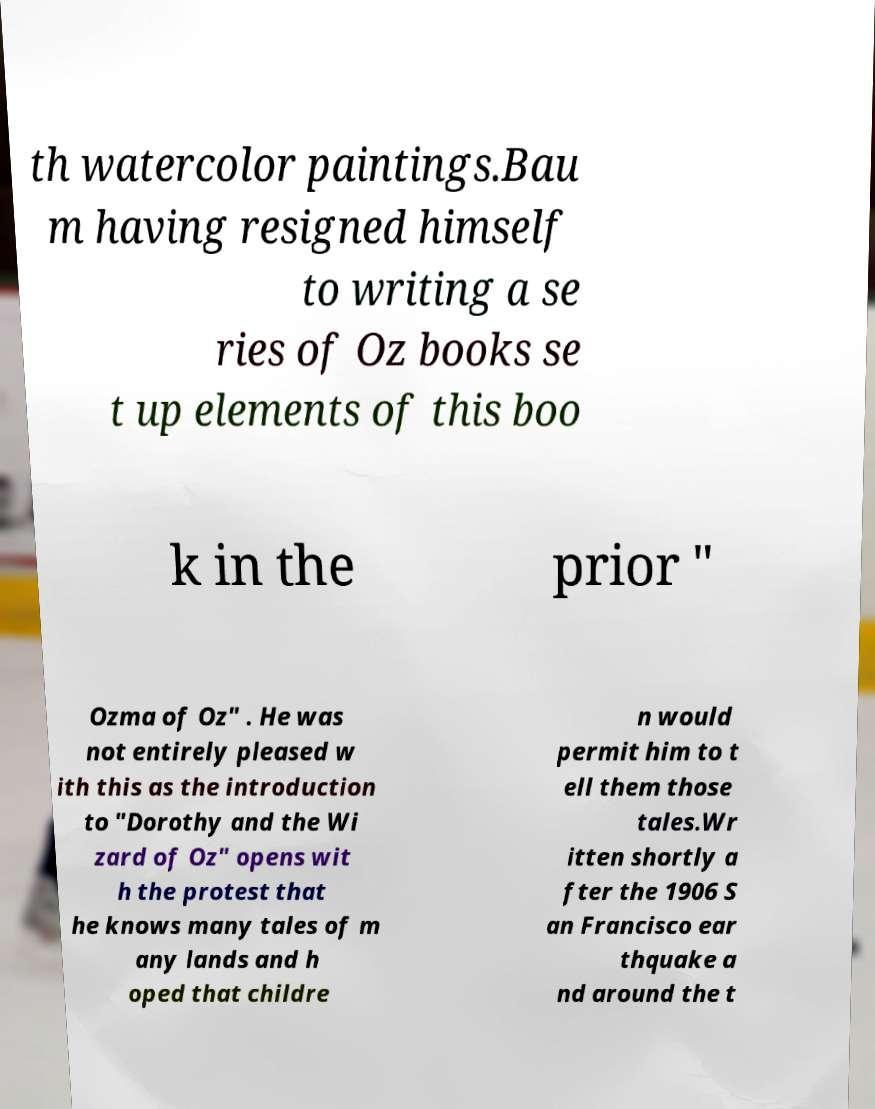Please read and relay the text visible in this image. What does it say? th watercolor paintings.Bau m having resigned himself to writing a se ries of Oz books se t up elements of this boo k in the prior " Ozma of Oz" . He was not entirely pleased w ith this as the introduction to "Dorothy and the Wi zard of Oz" opens wit h the protest that he knows many tales of m any lands and h oped that childre n would permit him to t ell them those tales.Wr itten shortly a fter the 1906 S an Francisco ear thquake a nd around the t 